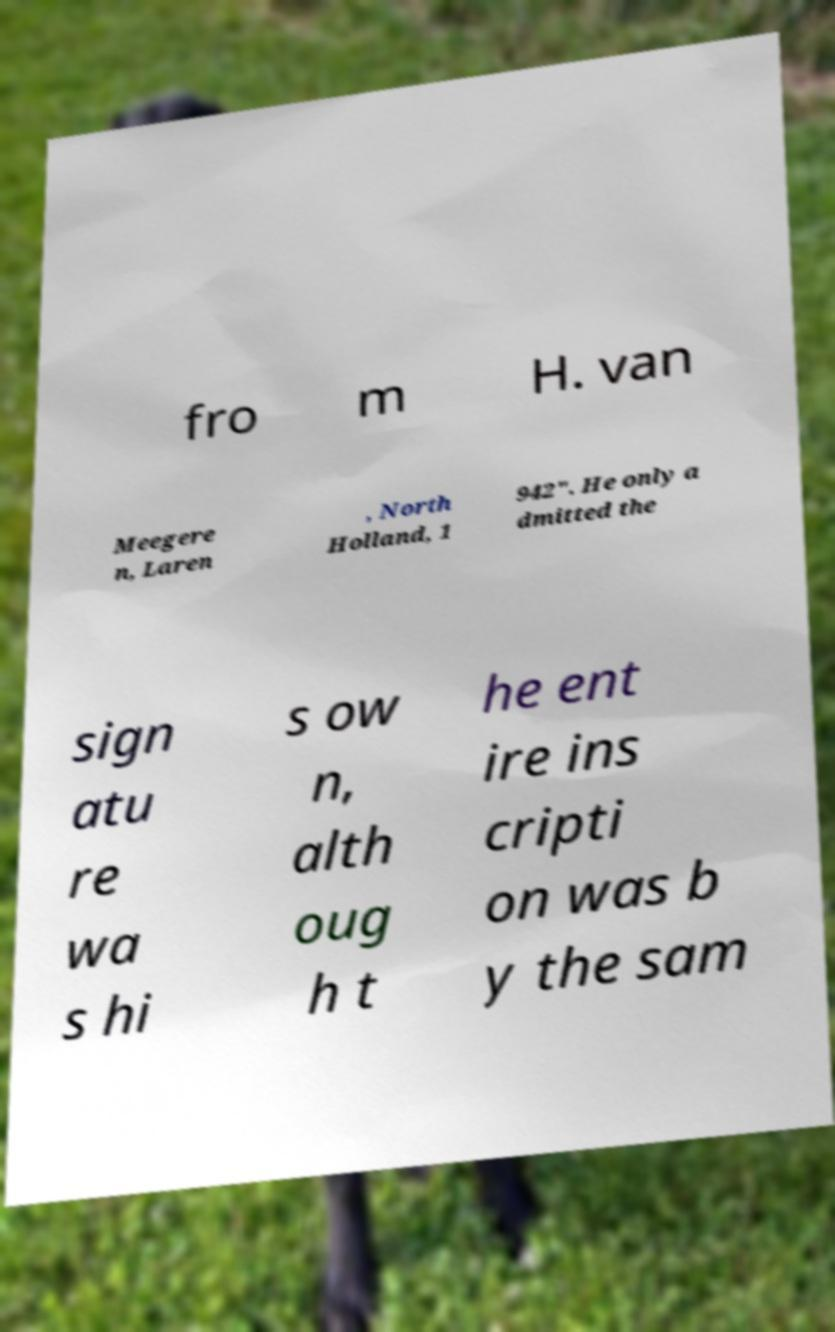Please identify and transcribe the text found in this image. fro m H. van Meegere n, Laren , North Holland, 1 942". He only a dmitted the sign atu re wa s hi s ow n, alth oug h t he ent ire ins cripti on was b y the sam 